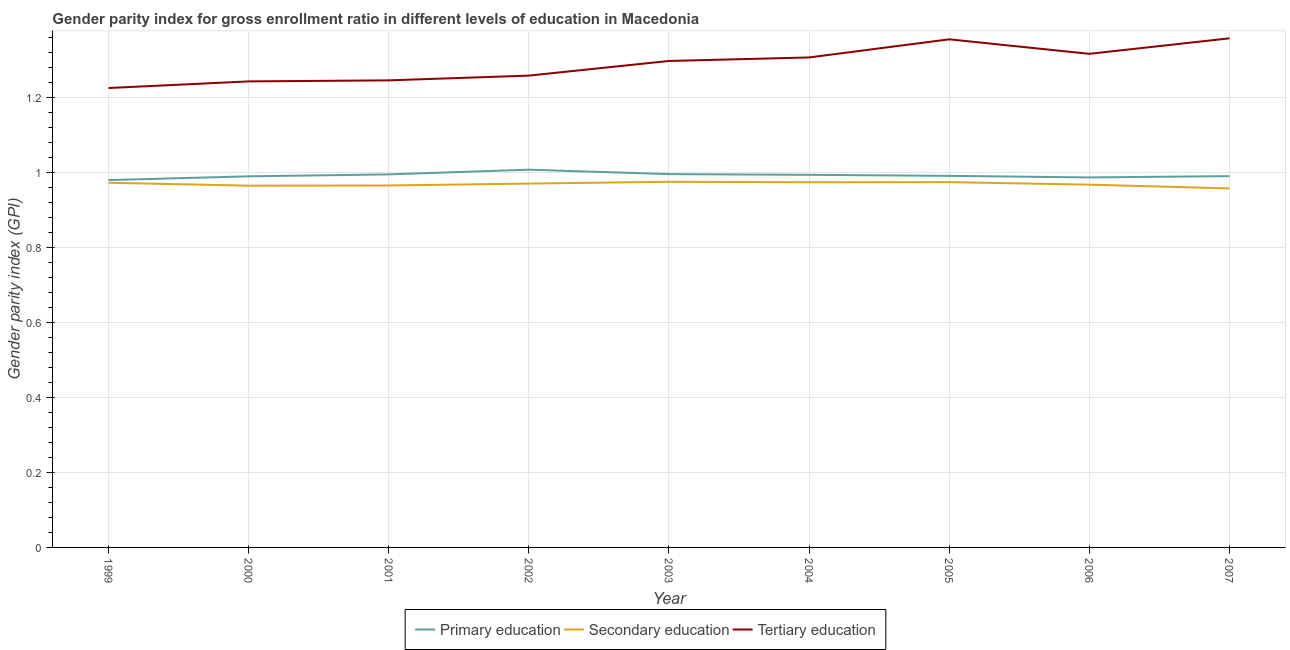Is the number of lines equal to the number of legend labels?
Keep it short and to the point. Yes. What is the gender parity index in secondary education in 2000?
Give a very brief answer. 0.97. Across all years, what is the maximum gender parity index in tertiary education?
Offer a very short reply. 1.36. Across all years, what is the minimum gender parity index in secondary education?
Make the answer very short. 0.96. What is the total gender parity index in tertiary education in the graph?
Keep it short and to the point. 11.61. What is the difference between the gender parity index in secondary education in 2005 and that in 2006?
Your response must be concise. 0.01. What is the difference between the gender parity index in tertiary education in 2007 and the gender parity index in primary education in 2000?
Offer a terse response. 0.37. What is the average gender parity index in tertiary education per year?
Offer a very short reply. 1.29. In the year 2000, what is the difference between the gender parity index in secondary education and gender parity index in primary education?
Provide a short and direct response. -0.02. What is the ratio of the gender parity index in primary education in 1999 to that in 2007?
Provide a succinct answer. 0.99. Is the gender parity index in primary education in 1999 less than that in 2006?
Keep it short and to the point. Yes. What is the difference between the highest and the second highest gender parity index in tertiary education?
Your response must be concise. 0. What is the difference between the highest and the lowest gender parity index in primary education?
Your response must be concise. 0.03. In how many years, is the gender parity index in tertiary education greater than the average gender parity index in tertiary education taken over all years?
Make the answer very short. 5. Is the sum of the gender parity index in secondary education in 2003 and 2006 greater than the maximum gender parity index in primary education across all years?
Provide a short and direct response. Yes. Is the gender parity index in primary education strictly greater than the gender parity index in secondary education over the years?
Provide a succinct answer. Yes. How many lines are there?
Provide a short and direct response. 3. What is the difference between two consecutive major ticks on the Y-axis?
Give a very brief answer. 0.2. Are the values on the major ticks of Y-axis written in scientific E-notation?
Your answer should be very brief. No. Does the graph contain any zero values?
Your answer should be very brief. No. Does the graph contain grids?
Keep it short and to the point. Yes. What is the title of the graph?
Your answer should be very brief. Gender parity index for gross enrollment ratio in different levels of education in Macedonia. Does "Communicable diseases" appear as one of the legend labels in the graph?
Your response must be concise. No. What is the label or title of the Y-axis?
Your response must be concise. Gender parity index (GPI). What is the Gender parity index (GPI) of Primary education in 1999?
Make the answer very short. 0.98. What is the Gender parity index (GPI) of Secondary education in 1999?
Make the answer very short. 0.97. What is the Gender parity index (GPI) in Tertiary education in 1999?
Your response must be concise. 1.23. What is the Gender parity index (GPI) in Primary education in 2000?
Provide a short and direct response. 0.99. What is the Gender parity index (GPI) in Secondary education in 2000?
Offer a very short reply. 0.97. What is the Gender parity index (GPI) of Tertiary education in 2000?
Keep it short and to the point. 1.24. What is the Gender parity index (GPI) in Primary education in 2001?
Give a very brief answer. 1. What is the Gender parity index (GPI) of Secondary education in 2001?
Keep it short and to the point. 0.97. What is the Gender parity index (GPI) of Tertiary education in 2001?
Give a very brief answer. 1.25. What is the Gender parity index (GPI) in Primary education in 2002?
Provide a short and direct response. 1.01. What is the Gender parity index (GPI) of Secondary education in 2002?
Make the answer very short. 0.97. What is the Gender parity index (GPI) in Tertiary education in 2002?
Your answer should be compact. 1.26. What is the Gender parity index (GPI) in Primary education in 2003?
Provide a short and direct response. 1. What is the Gender parity index (GPI) of Secondary education in 2003?
Make the answer very short. 0.98. What is the Gender parity index (GPI) in Tertiary education in 2003?
Your answer should be very brief. 1.3. What is the Gender parity index (GPI) in Primary education in 2004?
Ensure brevity in your answer.  0.99. What is the Gender parity index (GPI) in Secondary education in 2004?
Your answer should be very brief. 0.97. What is the Gender parity index (GPI) in Tertiary education in 2004?
Ensure brevity in your answer.  1.31. What is the Gender parity index (GPI) of Primary education in 2005?
Your response must be concise. 0.99. What is the Gender parity index (GPI) of Secondary education in 2005?
Give a very brief answer. 0.97. What is the Gender parity index (GPI) of Tertiary education in 2005?
Give a very brief answer. 1.36. What is the Gender parity index (GPI) in Primary education in 2006?
Ensure brevity in your answer.  0.99. What is the Gender parity index (GPI) of Secondary education in 2006?
Your answer should be compact. 0.97. What is the Gender parity index (GPI) of Tertiary education in 2006?
Provide a succinct answer. 1.32. What is the Gender parity index (GPI) in Primary education in 2007?
Ensure brevity in your answer.  0.99. What is the Gender parity index (GPI) of Secondary education in 2007?
Give a very brief answer. 0.96. What is the Gender parity index (GPI) of Tertiary education in 2007?
Make the answer very short. 1.36. Across all years, what is the maximum Gender parity index (GPI) in Primary education?
Your answer should be compact. 1.01. Across all years, what is the maximum Gender parity index (GPI) in Secondary education?
Keep it short and to the point. 0.98. Across all years, what is the maximum Gender parity index (GPI) in Tertiary education?
Ensure brevity in your answer.  1.36. Across all years, what is the minimum Gender parity index (GPI) in Primary education?
Provide a short and direct response. 0.98. Across all years, what is the minimum Gender parity index (GPI) in Secondary education?
Provide a succinct answer. 0.96. Across all years, what is the minimum Gender parity index (GPI) of Tertiary education?
Your answer should be compact. 1.23. What is the total Gender parity index (GPI) of Primary education in the graph?
Offer a terse response. 8.94. What is the total Gender parity index (GPI) of Secondary education in the graph?
Your answer should be very brief. 8.73. What is the total Gender parity index (GPI) in Tertiary education in the graph?
Keep it short and to the point. 11.61. What is the difference between the Gender parity index (GPI) of Primary education in 1999 and that in 2000?
Your answer should be compact. -0.01. What is the difference between the Gender parity index (GPI) in Secondary education in 1999 and that in 2000?
Keep it short and to the point. 0.01. What is the difference between the Gender parity index (GPI) in Tertiary education in 1999 and that in 2000?
Offer a terse response. -0.02. What is the difference between the Gender parity index (GPI) of Primary education in 1999 and that in 2001?
Your answer should be very brief. -0.02. What is the difference between the Gender parity index (GPI) in Secondary education in 1999 and that in 2001?
Keep it short and to the point. 0.01. What is the difference between the Gender parity index (GPI) in Tertiary education in 1999 and that in 2001?
Your answer should be compact. -0.02. What is the difference between the Gender parity index (GPI) of Primary education in 1999 and that in 2002?
Your response must be concise. -0.03. What is the difference between the Gender parity index (GPI) of Secondary education in 1999 and that in 2002?
Offer a very short reply. 0. What is the difference between the Gender parity index (GPI) in Tertiary education in 1999 and that in 2002?
Keep it short and to the point. -0.03. What is the difference between the Gender parity index (GPI) in Primary education in 1999 and that in 2003?
Your answer should be compact. -0.02. What is the difference between the Gender parity index (GPI) in Secondary education in 1999 and that in 2003?
Offer a terse response. -0. What is the difference between the Gender parity index (GPI) in Tertiary education in 1999 and that in 2003?
Offer a very short reply. -0.07. What is the difference between the Gender parity index (GPI) of Primary education in 1999 and that in 2004?
Your answer should be very brief. -0.01. What is the difference between the Gender parity index (GPI) in Secondary education in 1999 and that in 2004?
Provide a short and direct response. -0. What is the difference between the Gender parity index (GPI) of Tertiary education in 1999 and that in 2004?
Provide a short and direct response. -0.08. What is the difference between the Gender parity index (GPI) of Primary education in 1999 and that in 2005?
Your answer should be compact. -0.01. What is the difference between the Gender parity index (GPI) of Secondary education in 1999 and that in 2005?
Your response must be concise. -0. What is the difference between the Gender parity index (GPI) of Tertiary education in 1999 and that in 2005?
Make the answer very short. -0.13. What is the difference between the Gender parity index (GPI) in Primary education in 1999 and that in 2006?
Provide a succinct answer. -0.01. What is the difference between the Gender parity index (GPI) in Secondary education in 1999 and that in 2006?
Your answer should be compact. 0.01. What is the difference between the Gender parity index (GPI) of Tertiary education in 1999 and that in 2006?
Your answer should be compact. -0.09. What is the difference between the Gender parity index (GPI) in Primary education in 1999 and that in 2007?
Your response must be concise. -0.01. What is the difference between the Gender parity index (GPI) in Secondary education in 1999 and that in 2007?
Give a very brief answer. 0.01. What is the difference between the Gender parity index (GPI) of Tertiary education in 1999 and that in 2007?
Give a very brief answer. -0.13. What is the difference between the Gender parity index (GPI) in Primary education in 2000 and that in 2001?
Make the answer very short. -0.01. What is the difference between the Gender parity index (GPI) in Secondary education in 2000 and that in 2001?
Your answer should be very brief. -0. What is the difference between the Gender parity index (GPI) of Tertiary education in 2000 and that in 2001?
Make the answer very short. -0. What is the difference between the Gender parity index (GPI) of Primary education in 2000 and that in 2002?
Provide a short and direct response. -0.02. What is the difference between the Gender parity index (GPI) of Secondary education in 2000 and that in 2002?
Give a very brief answer. -0.01. What is the difference between the Gender parity index (GPI) of Tertiary education in 2000 and that in 2002?
Make the answer very short. -0.02. What is the difference between the Gender parity index (GPI) of Primary education in 2000 and that in 2003?
Make the answer very short. -0.01. What is the difference between the Gender parity index (GPI) in Secondary education in 2000 and that in 2003?
Your answer should be compact. -0.01. What is the difference between the Gender parity index (GPI) in Tertiary education in 2000 and that in 2003?
Offer a very short reply. -0.05. What is the difference between the Gender parity index (GPI) in Primary education in 2000 and that in 2004?
Offer a terse response. -0. What is the difference between the Gender parity index (GPI) in Secondary education in 2000 and that in 2004?
Your response must be concise. -0.01. What is the difference between the Gender parity index (GPI) of Tertiary education in 2000 and that in 2004?
Offer a terse response. -0.06. What is the difference between the Gender parity index (GPI) of Primary education in 2000 and that in 2005?
Your answer should be very brief. -0. What is the difference between the Gender parity index (GPI) of Secondary education in 2000 and that in 2005?
Your answer should be compact. -0.01. What is the difference between the Gender parity index (GPI) of Tertiary education in 2000 and that in 2005?
Ensure brevity in your answer.  -0.11. What is the difference between the Gender parity index (GPI) of Primary education in 2000 and that in 2006?
Keep it short and to the point. 0. What is the difference between the Gender parity index (GPI) in Secondary education in 2000 and that in 2006?
Provide a short and direct response. -0. What is the difference between the Gender parity index (GPI) of Tertiary education in 2000 and that in 2006?
Give a very brief answer. -0.07. What is the difference between the Gender parity index (GPI) of Primary education in 2000 and that in 2007?
Give a very brief answer. -0. What is the difference between the Gender parity index (GPI) of Secondary education in 2000 and that in 2007?
Keep it short and to the point. 0.01. What is the difference between the Gender parity index (GPI) in Tertiary education in 2000 and that in 2007?
Your response must be concise. -0.11. What is the difference between the Gender parity index (GPI) in Primary education in 2001 and that in 2002?
Your answer should be very brief. -0.01. What is the difference between the Gender parity index (GPI) of Secondary education in 2001 and that in 2002?
Make the answer very short. -0.01. What is the difference between the Gender parity index (GPI) of Tertiary education in 2001 and that in 2002?
Keep it short and to the point. -0.01. What is the difference between the Gender parity index (GPI) of Primary education in 2001 and that in 2003?
Provide a succinct answer. -0. What is the difference between the Gender parity index (GPI) of Secondary education in 2001 and that in 2003?
Ensure brevity in your answer.  -0.01. What is the difference between the Gender parity index (GPI) in Tertiary education in 2001 and that in 2003?
Your answer should be very brief. -0.05. What is the difference between the Gender parity index (GPI) of Primary education in 2001 and that in 2004?
Give a very brief answer. 0. What is the difference between the Gender parity index (GPI) of Secondary education in 2001 and that in 2004?
Provide a succinct answer. -0.01. What is the difference between the Gender parity index (GPI) of Tertiary education in 2001 and that in 2004?
Ensure brevity in your answer.  -0.06. What is the difference between the Gender parity index (GPI) of Primary education in 2001 and that in 2005?
Keep it short and to the point. 0. What is the difference between the Gender parity index (GPI) in Secondary education in 2001 and that in 2005?
Provide a short and direct response. -0.01. What is the difference between the Gender parity index (GPI) of Tertiary education in 2001 and that in 2005?
Make the answer very short. -0.11. What is the difference between the Gender parity index (GPI) of Primary education in 2001 and that in 2006?
Your answer should be very brief. 0.01. What is the difference between the Gender parity index (GPI) of Secondary education in 2001 and that in 2006?
Keep it short and to the point. -0. What is the difference between the Gender parity index (GPI) in Tertiary education in 2001 and that in 2006?
Make the answer very short. -0.07. What is the difference between the Gender parity index (GPI) of Primary education in 2001 and that in 2007?
Offer a terse response. 0. What is the difference between the Gender parity index (GPI) in Secondary education in 2001 and that in 2007?
Offer a terse response. 0.01. What is the difference between the Gender parity index (GPI) in Tertiary education in 2001 and that in 2007?
Your answer should be very brief. -0.11. What is the difference between the Gender parity index (GPI) of Primary education in 2002 and that in 2003?
Keep it short and to the point. 0.01. What is the difference between the Gender parity index (GPI) in Secondary education in 2002 and that in 2003?
Give a very brief answer. -0. What is the difference between the Gender parity index (GPI) in Tertiary education in 2002 and that in 2003?
Your answer should be compact. -0.04. What is the difference between the Gender parity index (GPI) of Primary education in 2002 and that in 2004?
Your answer should be very brief. 0.01. What is the difference between the Gender parity index (GPI) of Secondary education in 2002 and that in 2004?
Offer a very short reply. -0. What is the difference between the Gender parity index (GPI) in Tertiary education in 2002 and that in 2004?
Give a very brief answer. -0.05. What is the difference between the Gender parity index (GPI) in Primary education in 2002 and that in 2005?
Your answer should be very brief. 0.02. What is the difference between the Gender parity index (GPI) of Secondary education in 2002 and that in 2005?
Provide a short and direct response. -0. What is the difference between the Gender parity index (GPI) in Tertiary education in 2002 and that in 2005?
Your response must be concise. -0.1. What is the difference between the Gender parity index (GPI) of Primary education in 2002 and that in 2006?
Make the answer very short. 0.02. What is the difference between the Gender parity index (GPI) in Secondary education in 2002 and that in 2006?
Offer a very short reply. 0. What is the difference between the Gender parity index (GPI) of Tertiary education in 2002 and that in 2006?
Offer a very short reply. -0.06. What is the difference between the Gender parity index (GPI) in Primary education in 2002 and that in 2007?
Ensure brevity in your answer.  0.02. What is the difference between the Gender parity index (GPI) in Secondary education in 2002 and that in 2007?
Provide a succinct answer. 0.01. What is the difference between the Gender parity index (GPI) of Tertiary education in 2002 and that in 2007?
Provide a succinct answer. -0.1. What is the difference between the Gender parity index (GPI) in Primary education in 2003 and that in 2004?
Give a very brief answer. 0. What is the difference between the Gender parity index (GPI) of Secondary education in 2003 and that in 2004?
Provide a short and direct response. 0. What is the difference between the Gender parity index (GPI) in Tertiary education in 2003 and that in 2004?
Offer a terse response. -0.01. What is the difference between the Gender parity index (GPI) of Primary education in 2003 and that in 2005?
Provide a succinct answer. 0. What is the difference between the Gender parity index (GPI) of Tertiary education in 2003 and that in 2005?
Your response must be concise. -0.06. What is the difference between the Gender parity index (GPI) of Primary education in 2003 and that in 2006?
Provide a succinct answer. 0.01. What is the difference between the Gender parity index (GPI) in Secondary education in 2003 and that in 2006?
Keep it short and to the point. 0.01. What is the difference between the Gender parity index (GPI) in Tertiary education in 2003 and that in 2006?
Your answer should be compact. -0.02. What is the difference between the Gender parity index (GPI) of Primary education in 2003 and that in 2007?
Give a very brief answer. 0.01. What is the difference between the Gender parity index (GPI) of Secondary education in 2003 and that in 2007?
Offer a very short reply. 0.02. What is the difference between the Gender parity index (GPI) in Tertiary education in 2003 and that in 2007?
Your response must be concise. -0.06. What is the difference between the Gender parity index (GPI) in Primary education in 2004 and that in 2005?
Your answer should be compact. 0. What is the difference between the Gender parity index (GPI) of Secondary education in 2004 and that in 2005?
Offer a terse response. -0. What is the difference between the Gender parity index (GPI) of Tertiary education in 2004 and that in 2005?
Provide a short and direct response. -0.05. What is the difference between the Gender parity index (GPI) of Primary education in 2004 and that in 2006?
Make the answer very short. 0.01. What is the difference between the Gender parity index (GPI) in Secondary education in 2004 and that in 2006?
Offer a terse response. 0.01. What is the difference between the Gender parity index (GPI) of Tertiary education in 2004 and that in 2006?
Provide a short and direct response. -0.01. What is the difference between the Gender parity index (GPI) in Primary education in 2004 and that in 2007?
Your response must be concise. 0. What is the difference between the Gender parity index (GPI) of Secondary education in 2004 and that in 2007?
Keep it short and to the point. 0.02. What is the difference between the Gender parity index (GPI) in Tertiary education in 2004 and that in 2007?
Ensure brevity in your answer.  -0.05. What is the difference between the Gender parity index (GPI) of Primary education in 2005 and that in 2006?
Your response must be concise. 0. What is the difference between the Gender parity index (GPI) of Secondary education in 2005 and that in 2006?
Keep it short and to the point. 0.01. What is the difference between the Gender parity index (GPI) of Tertiary education in 2005 and that in 2006?
Keep it short and to the point. 0.04. What is the difference between the Gender parity index (GPI) of Primary education in 2005 and that in 2007?
Provide a succinct answer. 0. What is the difference between the Gender parity index (GPI) in Secondary education in 2005 and that in 2007?
Keep it short and to the point. 0.02. What is the difference between the Gender parity index (GPI) in Tertiary education in 2005 and that in 2007?
Offer a terse response. -0. What is the difference between the Gender parity index (GPI) of Primary education in 2006 and that in 2007?
Offer a very short reply. -0. What is the difference between the Gender parity index (GPI) of Tertiary education in 2006 and that in 2007?
Offer a terse response. -0.04. What is the difference between the Gender parity index (GPI) of Primary education in 1999 and the Gender parity index (GPI) of Secondary education in 2000?
Provide a succinct answer. 0.01. What is the difference between the Gender parity index (GPI) in Primary education in 1999 and the Gender parity index (GPI) in Tertiary education in 2000?
Offer a very short reply. -0.26. What is the difference between the Gender parity index (GPI) in Secondary education in 1999 and the Gender parity index (GPI) in Tertiary education in 2000?
Provide a short and direct response. -0.27. What is the difference between the Gender parity index (GPI) in Primary education in 1999 and the Gender parity index (GPI) in Secondary education in 2001?
Your answer should be compact. 0.01. What is the difference between the Gender parity index (GPI) in Primary education in 1999 and the Gender parity index (GPI) in Tertiary education in 2001?
Provide a short and direct response. -0.27. What is the difference between the Gender parity index (GPI) in Secondary education in 1999 and the Gender parity index (GPI) in Tertiary education in 2001?
Your answer should be very brief. -0.27. What is the difference between the Gender parity index (GPI) of Primary education in 1999 and the Gender parity index (GPI) of Secondary education in 2002?
Your answer should be compact. 0.01. What is the difference between the Gender parity index (GPI) of Primary education in 1999 and the Gender parity index (GPI) of Tertiary education in 2002?
Provide a succinct answer. -0.28. What is the difference between the Gender parity index (GPI) in Secondary education in 1999 and the Gender parity index (GPI) in Tertiary education in 2002?
Ensure brevity in your answer.  -0.29. What is the difference between the Gender parity index (GPI) in Primary education in 1999 and the Gender parity index (GPI) in Secondary education in 2003?
Provide a succinct answer. 0. What is the difference between the Gender parity index (GPI) of Primary education in 1999 and the Gender parity index (GPI) of Tertiary education in 2003?
Make the answer very short. -0.32. What is the difference between the Gender parity index (GPI) in Secondary education in 1999 and the Gender parity index (GPI) in Tertiary education in 2003?
Offer a very short reply. -0.33. What is the difference between the Gender parity index (GPI) in Primary education in 1999 and the Gender parity index (GPI) in Secondary education in 2004?
Give a very brief answer. 0.01. What is the difference between the Gender parity index (GPI) of Primary education in 1999 and the Gender parity index (GPI) of Tertiary education in 2004?
Ensure brevity in your answer.  -0.33. What is the difference between the Gender parity index (GPI) in Secondary education in 1999 and the Gender parity index (GPI) in Tertiary education in 2004?
Offer a very short reply. -0.33. What is the difference between the Gender parity index (GPI) of Primary education in 1999 and the Gender parity index (GPI) of Secondary education in 2005?
Keep it short and to the point. 0.01. What is the difference between the Gender parity index (GPI) in Primary education in 1999 and the Gender parity index (GPI) in Tertiary education in 2005?
Offer a very short reply. -0.38. What is the difference between the Gender parity index (GPI) of Secondary education in 1999 and the Gender parity index (GPI) of Tertiary education in 2005?
Provide a short and direct response. -0.38. What is the difference between the Gender parity index (GPI) in Primary education in 1999 and the Gender parity index (GPI) in Secondary education in 2006?
Offer a very short reply. 0.01. What is the difference between the Gender parity index (GPI) of Primary education in 1999 and the Gender parity index (GPI) of Tertiary education in 2006?
Keep it short and to the point. -0.34. What is the difference between the Gender parity index (GPI) of Secondary education in 1999 and the Gender parity index (GPI) of Tertiary education in 2006?
Your response must be concise. -0.34. What is the difference between the Gender parity index (GPI) of Primary education in 1999 and the Gender parity index (GPI) of Secondary education in 2007?
Ensure brevity in your answer.  0.02. What is the difference between the Gender parity index (GPI) of Primary education in 1999 and the Gender parity index (GPI) of Tertiary education in 2007?
Your answer should be compact. -0.38. What is the difference between the Gender parity index (GPI) in Secondary education in 1999 and the Gender parity index (GPI) in Tertiary education in 2007?
Offer a terse response. -0.39. What is the difference between the Gender parity index (GPI) of Primary education in 2000 and the Gender parity index (GPI) of Secondary education in 2001?
Make the answer very short. 0.02. What is the difference between the Gender parity index (GPI) of Primary education in 2000 and the Gender parity index (GPI) of Tertiary education in 2001?
Ensure brevity in your answer.  -0.26. What is the difference between the Gender parity index (GPI) of Secondary education in 2000 and the Gender parity index (GPI) of Tertiary education in 2001?
Ensure brevity in your answer.  -0.28. What is the difference between the Gender parity index (GPI) of Primary education in 2000 and the Gender parity index (GPI) of Secondary education in 2002?
Your response must be concise. 0.02. What is the difference between the Gender parity index (GPI) in Primary education in 2000 and the Gender parity index (GPI) in Tertiary education in 2002?
Give a very brief answer. -0.27. What is the difference between the Gender parity index (GPI) in Secondary education in 2000 and the Gender parity index (GPI) in Tertiary education in 2002?
Keep it short and to the point. -0.29. What is the difference between the Gender parity index (GPI) of Primary education in 2000 and the Gender parity index (GPI) of Secondary education in 2003?
Make the answer very short. 0.01. What is the difference between the Gender parity index (GPI) of Primary education in 2000 and the Gender parity index (GPI) of Tertiary education in 2003?
Make the answer very short. -0.31. What is the difference between the Gender parity index (GPI) of Secondary education in 2000 and the Gender parity index (GPI) of Tertiary education in 2003?
Make the answer very short. -0.33. What is the difference between the Gender parity index (GPI) in Primary education in 2000 and the Gender parity index (GPI) in Secondary education in 2004?
Provide a short and direct response. 0.02. What is the difference between the Gender parity index (GPI) of Primary education in 2000 and the Gender parity index (GPI) of Tertiary education in 2004?
Provide a short and direct response. -0.32. What is the difference between the Gender parity index (GPI) of Secondary education in 2000 and the Gender parity index (GPI) of Tertiary education in 2004?
Your answer should be compact. -0.34. What is the difference between the Gender parity index (GPI) of Primary education in 2000 and the Gender parity index (GPI) of Secondary education in 2005?
Offer a very short reply. 0.02. What is the difference between the Gender parity index (GPI) of Primary education in 2000 and the Gender parity index (GPI) of Tertiary education in 2005?
Offer a very short reply. -0.37. What is the difference between the Gender parity index (GPI) in Secondary education in 2000 and the Gender parity index (GPI) in Tertiary education in 2005?
Make the answer very short. -0.39. What is the difference between the Gender parity index (GPI) in Primary education in 2000 and the Gender parity index (GPI) in Secondary education in 2006?
Your response must be concise. 0.02. What is the difference between the Gender parity index (GPI) of Primary education in 2000 and the Gender parity index (GPI) of Tertiary education in 2006?
Your response must be concise. -0.33. What is the difference between the Gender parity index (GPI) in Secondary education in 2000 and the Gender parity index (GPI) in Tertiary education in 2006?
Your answer should be compact. -0.35. What is the difference between the Gender parity index (GPI) in Primary education in 2000 and the Gender parity index (GPI) in Secondary education in 2007?
Provide a succinct answer. 0.03. What is the difference between the Gender parity index (GPI) of Primary education in 2000 and the Gender parity index (GPI) of Tertiary education in 2007?
Your answer should be compact. -0.37. What is the difference between the Gender parity index (GPI) of Secondary education in 2000 and the Gender parity index (GPI) of Tertiary education in 2007?
Your response must be concise. -0.39. What is the difference between the Gender parity index (GPI) of Primary education in 2001 and the Gender parity index (GPI) of Secondary education in 2002?
Provide a succinct answer. 0.02. What is the difference between the Gender parity index (GPI) of Primary education in 2001 and the Gender parity index (GPI) of Tertiary education in 2002?
Give a very brief answer. -0.26. What is the difference between the Gender parity index (GPI) in Secondary education in 2001 and the Gender parity index (GPI) in Tertiary education in 2002?
Give a very brief answer. -0.29. What is the difference between the Gender parity index (GPI) in Primary education in 2001 and the Gender parity index (GPI) in Secondary education in 2003?
Ensure brevity in your answer.  0.02. What is the difference between the Gender parity index (GPI) in Primary education in 2001 and the Gender parity index (GPI) in Tertiary education in 2003?
Your answer should be compact. -0.3. What is the difference between the Gender parity index (GPI) in Secondary education in 2001 and the Gender parity index (GPI) in Tertiary education in 2003?
Provide a short and direct response. -0.33. What is the difference between the Gender parity index (GPI) in Primary education in 2001 and the Gender parity index (GPI) in Secondary education in 2004?
Keep it short and to the point. 0.02. What is the difference between the Gender parity index (GPI) in Primary education in 2001 and the Gender parity index (GPI) in Tertiary education in 2004?
Your answer should be very brief. -0.31. What is the difference between the Gender parity index (GPI) in Secondary education in 2001 and the Gender parity index (GPI) in Tertiary education in 2004?
Offer a very short reply. -0.34. What is the difference between the Gender parity index (GPI) in Primary education in 2001 and the Gender parity index (GPI) in Secondary education in 2005?
Make the answer very short. 0.02. What is the difference between the Gender parity index (GPI) of Primary education in 2001 and the Gender parity index (GPI) of Tertiary education in 2005?
Offer a very short reply. -0.36. What is the difference between the Gender parity index (GPI) of Secondary education in 2001 and the Gender parity index (GPI) of Tertiary education in 2005?
Provide a succinct answer. -0.39. What is the difference between the Gender parity index (GPI) of Primary education in 2001 and the Gender parity index (GPI) of Secondary education in 2006?
Your answer should be compact. 0.03. What is the difference between the Gender parity index (GPI) of Primary education in 2001 and the Gender parity index (GPI) of Tertiary education in 2006?
Provide a succinct answer. -0.32. What is the difference between the Gender parity index (GPI) of Secondary education in 2001 and the Gender parity index (GPI) of Tertiary education in 2006?
Give a very brief answer. -0.35. What is the difference between the Gender parity index (GPI) in Primary education in 2001 and the Gender parity index (GPI) in Secondary education in 2007?
Offer a very short reply. 0.04. What is the difference between the Gender parity index (GPI) of Primary education in 2001 and the Gender parity index (GPI) of Tertiary education in 2007?
Your response must be concise. -0.36. What is the difference between the Gender parity index (GPI) of Secondary education in 2001 and the Gender parity index (GPI) of Tertiary education in 2007?
Ensure brevity in your answer.  -0.39. What is the difference between the Gender parity index (GPI) in Primary education in 2002 and the Gender parity index (GPI) in Secondary education in 2003?
Make the answer very short. 0.03. What is the difference between the Gender parity index (GPI) of Primary education in 2002 and the Gender parity index (GPI) of Tertiary education in 2003?
Provide a succinct answer. -0.29. What is the difference between the Gender parity index (GPI) in Secondary education in 2002 and the Gender parity index (GPI) in Tertiary education in 2003?
Your answer should be very brief. -0.33. What is the difference between the Gender parity index (GPI) of Primary education in 2002 and the Gender parity index (GPI) of Secondary education in 2004?
Your response must be concise. 0.03. What is the difference between the Gender parity index (GPI) in Primary education in 2002 and the Gender parity index (GPI) in Tertiary education in 2004?
Offer a terse response. -0.3. What is the difference between the Gender parity index (GPI) of Secondary education in 2002 and the Gender parity index (GPI) of Tertiary education in 2004?
Provide a succinct answer. -0.34. What is the difference between the Gender parity index (GPI) of Primary education in 2002 and the Gender parity index (GPI) of Secondary education in 2005?
Make the answer very short. 0.03. What is the difference between the Gender parity index (GPI) of Primary education in 2002 and the Gender parity index (GPI) of Tertiary education in 2005?
Your answer should be very brief. -0.35. What is the difference between the Gender parity index (GPI) in Secondary education in 2002 and the Gender parity index (GPI) in Tertiary education in 2005?
Provide a short and direct response. -0.39. What is the difference between the Gender parity index (GPI) of Primary education in 2002 and the Gender parity index (GPI) of Secondary education in 2006?
Ensure brevity in your answer.  0.04. What is the difference between the Gender parity index (GPI) in Primary education in 2002 and the Gender parity index (GPI) in Tertiary education in 2006?
Provide a succinct answer. -0.31. What is the difference between the Gender parity index (GPI) of Secondary education in 2002 and the Gender parity index (GPI) of Tertiary education in 2006?
Offer a very short reply. -0.35. What is the difference between the Gender parity index (GPI) in Primary education in 2002 and the Gender parity index (GPI) in Secondary education in 2007?
Your answer should be very brief. 0.05. What is the difference between the Gender parity index (GPI) in Primary education in 2002 and the Gender parity index (GPI) in Tertiary education in 2007?
Ensure brevity in your answer.  -0.35. What is the difference between the Gender parity index (GPI) in Secondary education in 2002 and the Gender parity index (GPI) in Tertiary education in 2007?
Keep it short and to the point. -0.39. What is the difference between the Gender parity index (GPI) of Primary education in 2003 and the Gender parity index (GPI) of Secondary education in 2004?
Your response must be concise. 0.02. What is the difference between the Gender parity index (GPI) of Primary education in 2003 and the Gender parity index (GPI) of Tertiary education in 2004?
Ensure brevity in your answer.  -0.31. What is the difference between the Gender parity index (GPI) in Secondary education in 2003 and the Gender parity index (GPI) in Tertiary education in 2004?
Provide a short and direct response. -0.33. What is the difference between the Gender parity index (GPI) in Primary education in 2003 and the Gender parity index (GPI) in Secondary education in 2005?
Provide a succinct answer. 0.02. What is the difference between the Gender parity index (GPI) in Primary education in 2003 and the Gender parity index (GPI) in Tertiary education in 2005?
Keep it short and to the point. -0.36. What is the difference between the Gender parity index (GPI) in Secondary education in 2003 and the Gender parity index (GPI) in Tertiary education in 2005?
Ensure brevity in your answer.  -0.38. What is the difference between the Gender parity index (GPI) in Primary education in 2003 and the Gender parity index (GPI) in Secondary education in 2006?
Keep it short and to the point. 0.03. What is the difference between the Gender parity index (GPI) of Primary education in 2003 and the Gender parity index (GPI) of Tertiary education in 2006?
Keep it short and to the point. -0.32. What is the difference between the Gender parity index (GPI) of Secondary education in 2003 and the Gender parity index (GPI) of Tertiary education in 2006?
Offer a terse response. -0.34. What is the difference between the Gender parity index (GPI) in Primary education in 2003 and the Gender parity index (GPI) in Secondary education in 2007?
Provide a succinct answer. 0.04. What is the difference between the Gender parity index (GPI) in Primary education in 2003 and the Gender parity index (GPI) in Tertiary education in 2007?
Your response must be concise. -0.36. What is the difference between the Gender parity index (GPI) of Secondary education in 2003 and the Gender parity index (GPI) of Tertiary education in 2007?
Provide a succinct answer. -0.38. What is the difference between the Gender parity index (GPI) in Primary education in 2004 and the Gender parity index (GPI) in Secondary education in 2005?
Your response must be concise. 0.02. What is the difference between the Gender parity index (GPI) in Primary education in 2004 and the Gender parity index (GPI) in Tertiary education in 2005?
Provide a succinct answer. -0.36. What is the difference between the Gender parity index (GPI) of Secondary education in 2004 and the Gender parity index (GPI) of Tertiary education in 2005?
Ensure brevity in your answer.  -0.38. What is the difference between the Gender parity index (GPI) in Primary education in 2004 and the Gender parity index (GPI) in Secondary education in 2006?
Keep it short and to the point. 0.03. What is the difference between the Gender parity index (GPI) in Primary education in 2004 and the Gender parity index (GPI) in Tertiary education in 2006?
Offer a terse response. -0.32. What is the difference between the Gender parity index (GPI) of Secondary education in 2004 and the Gender parity index (GPI) of Tertiary education in 2006?
Your answer should be compact. -0.34. What is the difference between the Gender parity index (GPI) of Primary education in 2004 and the Gender parity index (GPI) of Secondary education in 2007?
Your answer should be very brief. 0.04. What is the difference between the Gender parity index (GPI) in Primary education in 2004 and the Gender parity index (GPI) in Tertiary education in 2007?
Keep it short and to the point. -0.36. What is the difference between the Gender parity index (GPI) of Secondary education in 2004 and the Gender parity index (GPI) of Tertiary education in 2007?
Your response must be concise. -0.38. What is the difference between the Gender parity index (GPI) of Primary education in 2005 and the Gender parity index (GPI) of Secondary education in 2006?
Give a very brief answer. 0.02. What is the difference between the Gender parity index (GPI) of Primary education in 2005 and the Gender parity index (GPI) of Tertiary education in 2006?
Your response must be concise. -0.33. What is the difference between the Gender parity index (GPI) in Secondary education in 2005 and the Gender parity index (GPI) in Tertiary education in 2006?
Provide a short and direct response. -0.34. What is the difference between the Gender parity index (GPI) of Primary education in 2005 and the Gender parity index (GPI) of Secondary education in 2007?
Make the answer very short. 0.03. What is the difference between the Gender parity index (GPI) of Primary education in 2005 and the Gender parity index (GPI) of Tertiary education in 2007?
Offer a terse response. -0.37. What is the difference between the Gender parity index (GPI) of Secondary education in 2005 and the Gender parity index (GPI) of Tertiary education in 2007?
Make the answer very short. -0.38. What is the difference between the Gender parity index (GPI) of Primary education in 2006 and the Gender parity index (GPI) of Secondary education in 2007?
Provide a succinct answer. 0.03. What is the difference between the Gender parity index (GPI) of Primary education in 2006 and the Gender parity index (GPI) of Tertiary education in 2007?
Ensure brevity in your answer.  -0.37. What is the difference between the Gender parity index (GPI) of Secondary education in 2006 and the Gender parity index (GPI) of Tertiary education in 2007?
Your answer should be very brief. -0.39. What is the average Gender parity index (GPI) of Secondary education per year?
Make the answer very short. 0.97. What is the average Gender parity index (GPI) in Tertiary education per year?
Make the answer very short. 1.29. In the year 1999, what is the difference between the Gender parity index (GPI) of Primary education and Gender parity index (GPI) of Secondary education?
Provide a succinct answer. 0.01. In the year 1999, what is the difference between the Gender parity index (GPI) in Primary education and Gender parity index (GPI) in Tertiary education?
Offer a terse response. -0.25. In the year 1999, what is the difference between the Gender parity index (GPI) in Secondary education and Gender parity index (GPI) in Tertiary education?
Make the answer very short. -0.25. In the year 2000, what is the difference between the Gender parity index (GPI) of Primary education and Gender parity index (GPI) of Secondary education?
Your response must be concise. 0.02. In the year 2000, what is the difference between the Gender parity index (GPI) of Primary education and Gender parity index (GPI) of Tertiary education?
Your answer should be very brief. -0.25. In the year 2000, what is the difference between the Gender parity index (GPI) of Secondary education and Gender parity index (GPI) of Tertiary education?
Your response must be concise. -0.28. In the year 2001, what is the difference between the Gender parity index (GPI) in Primary education and Gender parity index (GPI) in Secondary education?
Provide a short and direct response. 0.03. In the year 2001, what is the difference between the Gender parity index (GPI) of Primary education and Gender parity index (GPI) of Tertiary education?
Your answer should be very brief. -0.25. In the year 2001, what is the difference between the Gender parity index (GPI) in Secondary education and Gender parity index (GPI) in Tertiary education?
Provide a succinct answer. -0.28. In the year 2002, what is the difference between the Gender parity index (GPI) in Primary education and Gender parity index (GPI) in Secondary education?
Provide a succinct answer. 0.04. In the year 2002, what is the difference between the Gender parity index (GPI) in Primary education and Gender parity index (GPI) in Tertiary education?
Offer a terse response. -0.25. In the year 2002, what is the difference between the Gender parity index (GPI) of Secondary education and Gender parity index (GPI) of Tertiary education?
Your answer should be compact. -0.29. In the year 2003, what is the difference between the Gender parity index (GPI) of Primary education and Gender parity index (GPI) of Secondary education?
Keep it short and to the point. 0.02. In the year 2003, what is the difference between the Gender parity index (GPI) in Primary education and Gender parity index (GPI) in Tertiary education?
Keep it short and to the point. -0.3. In the year 2003, what is the difference between the Gender parity index (GPI) of Secondary education and Gender parity index (GPI) of Tertiary education?
Offer a terse response. -0.32. In the year 2004, what is the difference between the Gender parity index (GPI) in Primary education and Gender parity index (GPI) in Secondary education?
Offer a terse response. 0.02. In the year 2004, what is the difference between the Gender parity index (GPI) of Primary education and Gender parity index (GPI) of Tertiary education?
Offer a very short reply. -0.31. In the year 2004, what is the difference between the Gender parity index (GPI) of Secondary education and Gender parity index (GPI) of Tertiary education?
Your answer should be very brief. -0.33. In the year 2005, what is the difference between the Gender parity index (GPI) of Primary education and Gender parity index (GPI) of Secondary education?
Provide a succinct answer. 0.02. In the year 2005, what is the difference between the Gender parity index (GPI) in Primary education and Gender parity index (GPI) in Tertiary education?
Your answer should be very brief. -0.36. In the year 2005, what is the difference between the Gender parity index (GPI) of Secondary education and Gender parity index (GPI) of Tertiary education?
Your answer should be compact. -0.38. In the year 2006, what is the difference between the Gender parity index (GPI) in Primary education and Gender parity index (GPI) in Secondary education?
Give a very brief answer. 0.02. In the year 2006, what is the difference between the Gender parity index (GPI) in Primary education and Gender parity index (GPI) in Tertiary education?
Keep it short and to the point. -0.33. In the year 2006, what is the difference between the Gender parity index (GPI) in Secondary education and Gender parity index (GPI) in Tertiary education?
Your answer should be compact. -0.35. In the year 2007, what is the difference between the Gender parity index (GPI) of Primary education and Gender parity index (GPI) of Secondary education?
Ensure brevity in your answer.  0.03. In the year 2007, what is the difference between the Gender parity index (GPI) of Primary education and Gender parity index (GPI) of Tertiary education?
Offer a terse response. -0.37. In the year 2007, what is the difference between the Gender parity index (GPI) in Secondary education and Gender parity index (GPI) in Tertiary education?
Offer a terse response. -0.4. What is the ratio of the Gender parity index (GPI) of Secondary education in 1999 to that in 2000?
Keep it short and to the point. 1.01. What is the ratio of the Gender parity index (GPI) in Tertiary education in 1999 to that in 2000?
Offer a very short reply. 0.99. What is the ratio of the Gender parity index (GPI) of Primary education in 1999 to that in 2001?
Offer a very short reply. 0.98. What is the ratio of the Gender parity index (GPI) in Secondary education in 1999 to that in 2001?
Your answer should be very brief. 1.01. What is the ratio of the Gender parity index (GPI) of Tertiary education in 1999 to that in 2001?
Your answer should be compact. 0.98. What is the ratio of the Gender parity index (GPI) in Primary education in 1999 to that in 2002?
Give a very brief answer. 0.97. What is the ratio of the Gender parity index (GPI) of Tertiary education in 1999 to that in 2002?
Your answer should be very brief. 0.97. What is the ratio of the Gender parity index (GPI) of Secondary education in 1999 to that in 2003?
Your answer should be compact. 1. What is the ratio of the Gender parity index (GPI) of Tertiary education in 1999 to that in 2003?
Offer a very short reply. 0.94. What is the ratio of the Gender parity index (GPI) of Primary education in 1999 to that in 2004?
Ensure brevity in your answer.  0.99. What is the ratio of the Gender parity index (GPI) in Tertiary education in 1999 to that in 2004?
Ensure brevity in your answer.  0.94. What is the ratio of the Gender parity index (GPI) in Primary education in 1999 to that in 2005?
Your answer should be very brief. 0.99. What is the ratio of the Gender parity index (GPI) of Tertiary education in 1999 to that in 2005?
Provide a short and direct response. 0.9. What is the ratio of the Gender parity index (GPI) in Tertiary education in 1999 to that in 2006?
Your answer should be compact. 0.93. What is the ratio of the Gender parity index (GPI) in Primary education in 1999 to that in 2007?
Offer a terse response. 0.99. What is the ratio of the Gender parity index (GPI) in Secondary education in 1999 to that in 2007?
Give a very brief answer. 1.02. What is the ratio of the Gender parity index (GPI) of Tertiary education in 1999 to that in 2007?
Make the answer very short. 0.9. What is the ratio of the Gender parity index (GPI) of Primary education in 2000 to that in 2001?
Ensure brevity in your answer.  0.99. What is the ratio of the Gender parity index (GPI) in Secondary education in 2000 to that in 2001?
Your answer should be compact. 1. What is the ratio of the Gender parity index (GPI) of Tertiary education in 2000 to that in 2001?
Ensure brevity in your answer.  1. What is the ratio of the Gender parity index (GPI) in Primary education in 2000 to that in 2002?
Give a very brief answer. 0.98. What is the ratio of the Gender parity index (GPI) in Secondary education in 2000 to that in 2002?
Your answer should be very brief. 0.99. What is the ratio of the Gender parity index (GPI) in Tertiary education in 2000 to that in 2002?
Make the answer very short. 0.99. What is the ratio of the Gender parity index (GPI) of Primary education in 2000 to that in 2003?
Offer a terse response. 0.99. What is the ratio of the Gender parity index (GPI) in Secondary education in 2000 to that in 2003?
Provide a succinct answer. 0.99. What is the ratio of the Gender parity index (GPI) in Tertiary education in 2000 to that in 2003?
Your answer should be very brief. 0.96. What is the ratio of the Gender parity index (GPI) in Primary education in 2000 to that in 2004?
Your answer should be very brief. 1. What is the ratio of the Gender parity index (GPI) of Secondary education in 2000 to that in 2004?
Offer a very short reply. 0.99. What is the ratio of the Gender parity index (GPI) in Tertiary education in 2000 to that in 2004?
Ensure brevity in your answer.  0.95. What is the ratio of the Gender parity index (GPI) in Primary education in 2000 to that in 2005?
Offer a terse response. 1. What is the ratio of the Gender parity index (GPI) of Secondary education in 2000 to that in 2005?
Keep it short and to the point. 0.99. What is the ratio of the Gender parity index (GPI) of Tertiary education in 2000 to that in 2005?
Provide a short and direct response. 0.92. What is the ratio of the Gender parity index (GPI) in Tertiary education in 2000 to that in 2006?
Keep it short and to the point. 0.94. What is the ratio of the Gender parity index (GPI) of Secondary education in 2000 to that in 2007?
Your answer should be very brief. 1.01. What is the ratio of the Gender parity index (GPI) in Tertiary education in 2000 to that in 2007?
Make the answer very short. 0.92. What is the ratio of the Gender parity index (GPI) of Primary education in 2001 to that in 2002?
Ensure brevity in your answer.  0.99. What is the ratio of the Gender parity index (GPI) of Secondary education in 2001 to that in 2002?
Your response must be concise. 0.99. What is the ratio of the Gender parity index (GPI) of Tertiary education in 2001 to that in 2003?
Give a very brief answer. 0.96. What is the ratio of the Gender parity index (GPI) of Secondary education in 2001 to that in 2004?
Offer a very short reply. 0.99. What is the ratio of the Gender parity index (GPI) of Tertiary education in 2001 to that in 2004?
Give a very brief answer. 0.95. What is the ratio of the Gender parity index (GPI) in Primary education in 2001 to that in 2005?
Provide a succinct answer. 1. What is the ratio of the Gender parity index (GPI) of Secondary education in 2001 to that in 2005?
Provide a short and direct response. 0.99. What is the ratio of the Gender parity index (GPI) of Tertiary education in 2001 to that in 2005?
Your response must be concise. 0.92. What is the ratio of the Gender parity index (GPI) of Primary education in 2001 to that in 2006?
Ensure brevity in your answer.  1.01. What is the ratio of the Gender parity index (GPI) of Secondary education in 2001 to that in 2006?
Give a very brief answer. 1. What is the ratio of the Gender parity index (GPI) of Tertiary education in 2001 to that in 2006?
Your answer should be compact. 0.95. What is the ratio of the Gender parity index (GPI) in Primary education in 2001 to that in 2007?
Your answer should be very brief. 1. What is the ratio of the Gender parity index (GPI) of Secondary education in 2001 to that in 2007?
Provide a short and direct response. 1.01. What is the ratio of the Gender parity index (GPI) of Tertiary education in 2001 to that in 2007?
Offer a terse response. 0.92. What is the ratio of the Gender parity index (GPI) in Primary education in 2002 to that in 2003?
Give a very brief answer. 1.01. What is the ratio of the Gender parity index (GPI) of Tertiary education in 2002 to that in 2003?
Provide a short and direct response. 0.97. What is the ratio of the Gender parity index (GPI) of Primary education in 2002 to that in 2004?
Provide a succinct answer. 1.01. What is the ratio of the Gender parity index (GPI) in Tertiary education in 2002 to that in 2004?
Provide a succinct answer. 0.96. What is the ratio of the Gender parity index (GPI) of Primary education in 2002 to that in 2005?
Provide a short and direct response. 1.02. What is the ratio of the Gender parity index (GPI) in Secondary education in 2002 to that in 2005?
Provide a short and direct response. 1. What is the ratio of the Gender parity index (GPI) in Tertiary education in 2002 to that in 2005?
Your answer should be very brief. 0.93. What is the ratio of the Gender parity index (GPI) in Primary education in 2002 to that in 2006?
Make the answer very short. 1.02. What is the ratio of the Gender parity index (GPI) of Secondary education in 2002 to that in 2006?
Your response must be concise. 1. What is the ratio of the Gender parity index (GPI) of Tertiary education in 2002 to that in 2006?
Provide a succinct answer. 0.96. What is the ratio of the Gender parity index (GPI) in Primary education in 2002 to that in 2007?
Your response must be concise. 1.02. What is the ratio of the Gender parity index (GPI) in Secondary education in 2002 to that in 2007?
Provide a succinct answer. 1.01. What is the ratio of the Gender parity index (GPI) in Tertiary education in 2002 to that in 2007?
Provide a short and direct response. 0.93. What is the ratio of the Gender parity index (GPI) of Primary education in 2003 to that in 2004?
Offer a terse response. 1. What is the ratio of the Gender parity index (GPI) in Tertiary education in 2003 to that in 2004?
Give a very brief answer. 0.99. What is the ratio of the Gender parity index (GPI) of Tertiary education in 2003 to that in 2005?
Keep it short and to the point. 0.96. What is the ratio of the Gender parity index (GPI) in Primary education in 2003 to that in 2006?
Offer a very short reply. 1.01. What is the ratio of the Gender parity index (GPI) in Secondary education in 2003 to that in 2006?
Provide a succinct answer. 1.01. What is the ratio of the Gender parity index (GPI) in Tertiary education in 2003 to that in 2006?
Keep it short and to the point. 0.99. What is the ratio of the Gender parity index (GPI) of Primary education in 2003 to that in 2007?
Provide a succinct answer. 1.01. What is the ratio of the Gender parity index (GPI) of Secondary education in 2003 to that in 2007?
Provide a succinct answer. 1.02. What is the ratio of the Gender parity index (GPI) in Tertiary education in 2003 to that in 2007?
Offer a terse response. 0.96. What is the ratio of the Gender parity index (GPI) in Secondary education in 2004 to that in 2005?
Offer a terse response. 1. What is the ratio of the Gender parity index (GPI) of Tertiary education in 2004 to that in 2005?
Give a very brief answer. 0.96. What is the ratio of the Gender parity index (GPI) of Secondary education in 2004 to that in 2006?
Make the answer very short. 1.01. What is the ratio of the Gender parity index (GPI) in Primary education in 2004 to that in 2007?
Keep it short and to the point. 1. What is the ratio of the Gender parity index (GPI) of Secondary education in 2004 to that in 2007?
Offer a very short reply. 1.02. What is the ratio of the Gender parity index (GPI) of Tertiary education in 2004 to that in 2007?
Offer a terse response. 0.96. What is the ratio of the Gender parity index (GPI) in Tertiary education in 2005 to that in 2006?
Give a very brief answer. 1.03. What is the ratio of the Gender parity index (GPI) in Primary education in 2005 to that in 2007?
Your answer should be compact. 1. What is the ratio of the Gender parity index (GPI) of Secondary education in 2005 to that in 2007?
Your answer should be compact. 1.02. What is the ratio of the Gender parity index (GPI) in Secondary education in 2006 to that in 2007?
Your answer should be compact. 1.01. What is the ratio of the Gender parity index (GPI) of Tertiary education in 2006 to that in 2007?
Offer a very short reply. 0.97. What is the difference between the highest and the second highest Gender parity index (GPI) in Primary education?
Make the answer very short. 0.01. What is the difference between the highest and the second highest Gender parity index (GPI) in Tertiary education?
Make the answer very short. 0. What is the difference between the highest and the lowest Gender parity index (GPI) of Primary education?
Give a very brief answer. 0.03. What is the difference between the highest and the lowest Gender parity index (GPI) in Secondary education?
Offer a terse response. 0.02. What is the difference between the highest and the lowest Gender parity index (GPI) of Tertiary education?
Keep it short and to the point. 0.13. 